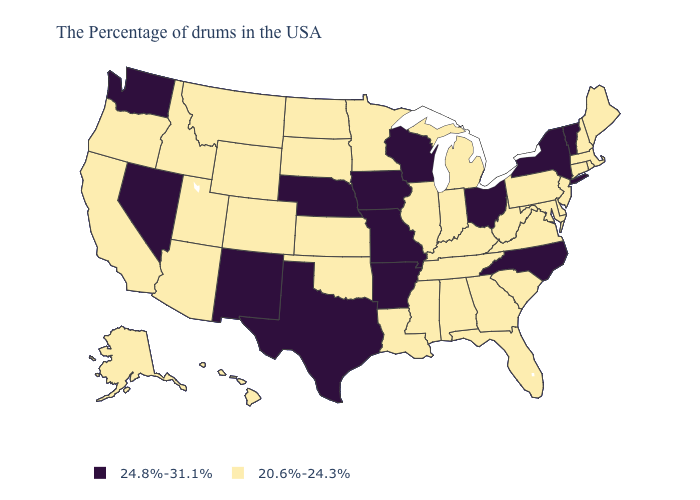What is the highest value in states that border Wisconsin?
Concise answer only. 24.8%-31.1%. Which states have the highest value in the USA?
Be succinct. Vermont, New York, North Carolina, Ohio, Wisconsin, Missouri, Arkansas, Iowa, Nebraska, Texas, New Mexico, Nevada, Washington. What is the value of Washington?
Keep it brief. 24.8%-31.1%. What is the value of Hawaii?
Quick response, please. 20.6%-24.3%. Which states have the lowest value in the USA?
Keep it brief. Maine, Massachusetts, Rhode Island, New Hampshire, Connecticut, New Jersey, Delaware, Maryland, Pennsylvania, Virginia, South Carolina, West Virginia, Florida, Georgia, Michigan, Kentucky, Indiana, Alabama, Tennessee, Illinois, Mississippi, Louisiana, Minnesota, Kansas, Oklahoma, South Dakota, North Dakota, Wyoming, Colorado, Utah, Montana, Arizona, Idaho, California, Oregon, Alaska, Hawaii. What is the value of North Dakota?
Be succinct. 20.6%-24.3%. Name the states that have a value in the range 24.8%-31.1%?
Give a very brief answer. Vermont, New York, North Carolina, Ohio, Wisconsin, Missouri, Arkansas, Iowa, Nebraska, Texas, New Mexico, Nevada, Washington. Name the states that have a value in the range 24.8%-31.1%?
Keep it brief. Vermont, New York, North Carolina, Ohio, Wisconsin, Missouri, Arkansas, Iowa, Nebraska, Texas, New Mexico, Nevada, Washington. What is the lowest value in the MidWest?
Keep it brief. 20.6%-24.3%. Does the first symbol in the legend represent the smallest category?
Give a very brief answer. No. What is the value of Alaska?
Be succinct. 20.6%-24.3%. Which states have the lowest value in the Northeast?
Keep it brief. Maine, Massachusetts, Rhode Island, New Hampshire, Connecticut, New Jersey, Pennsylvania. Name the states that have a value in the range 20.6%-24.3%?
Be succinct. Maine, Massachusetts, Rhode Island, New Hampshire, Connecticut, New Jersey, Delaware, Maryland, Pennsylvania, Virginia, South Carolina, West Virginia, Florida, Georgia, Michigan, Kentucky, Indiana, Alabama, Tennessee, Illinois, Mississippi, Louisiana, Minnesota, Kansas, Oklahoma, South Dakota, North Dakota, Wyoming, Colorado, Utah, Montana, Arizona, Idaho, California, Oregon, Alaska, Hawaii. Which states hav the highest value in the South?
Give a very brief answer. North Carolina, Arkansas, Texas. Does New Jersey have a higher value than Michigan?
Be succinct. No. 